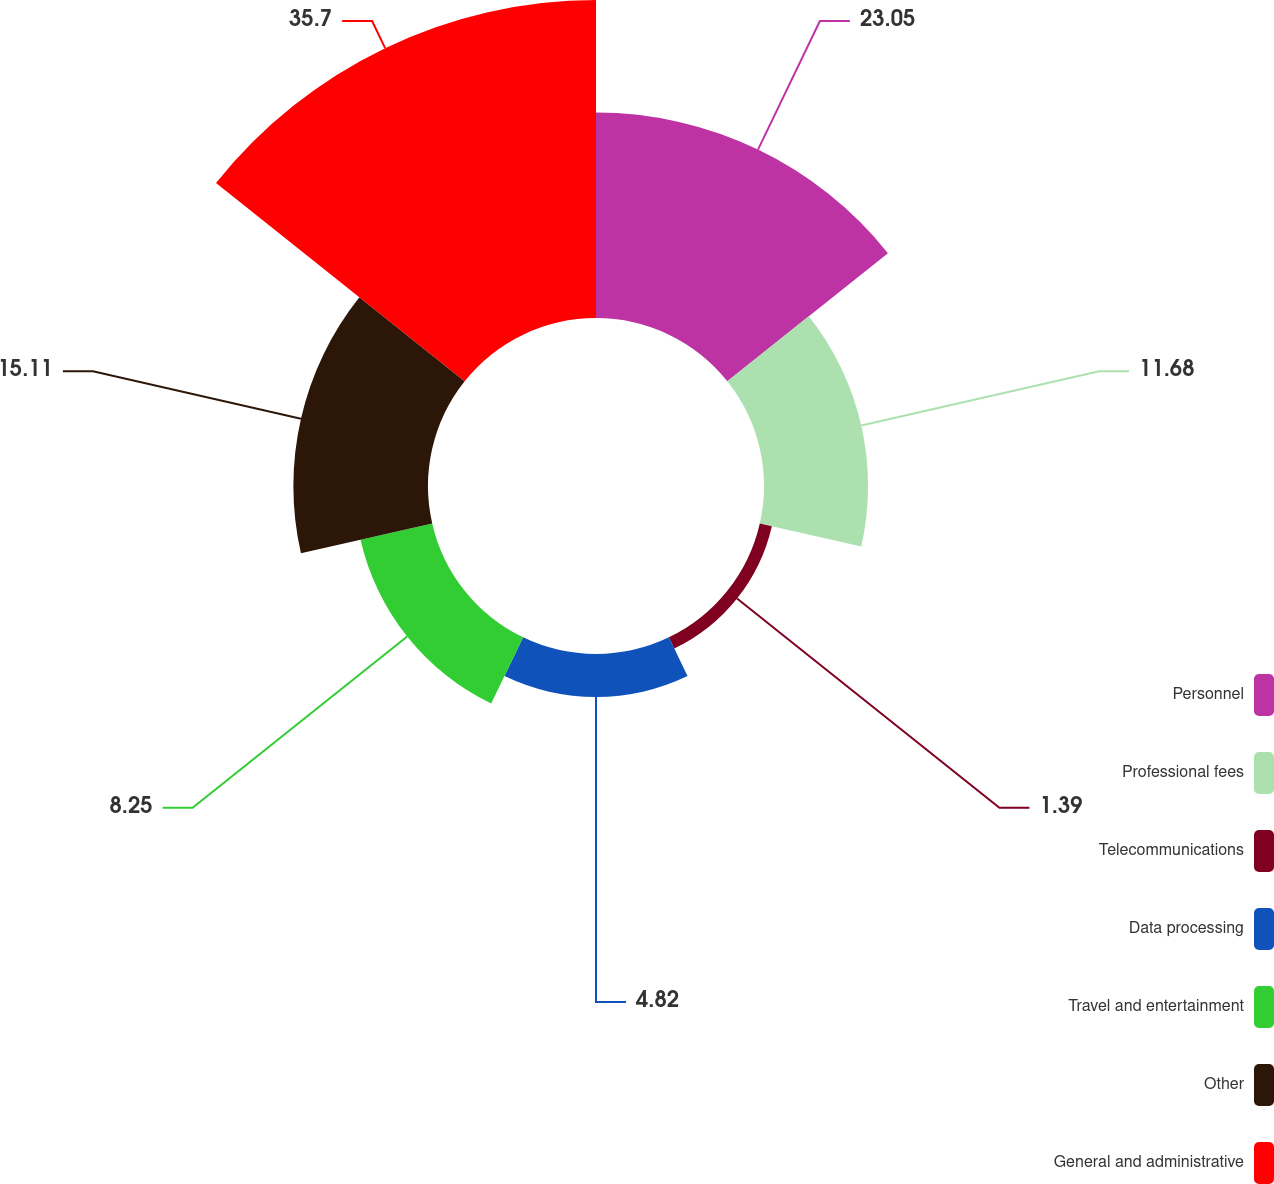Convert chart to OTSL. <chart><loc_0><loc_0><loc_500><loc_500><pie_chart><fcel>Personnel<fcel>Professional fees<fcel>Telecommunications<fcel>Data processing<fcel>Travel and entertainment<fcel>Other<fcel>General and administrative<nl><fcel>23.05%<fcel>11.68%<fcel>1.39%<fcel>4.82%<fcel>8.25%<fcel>15.11%<fcel>35.69%<nl></chart> 